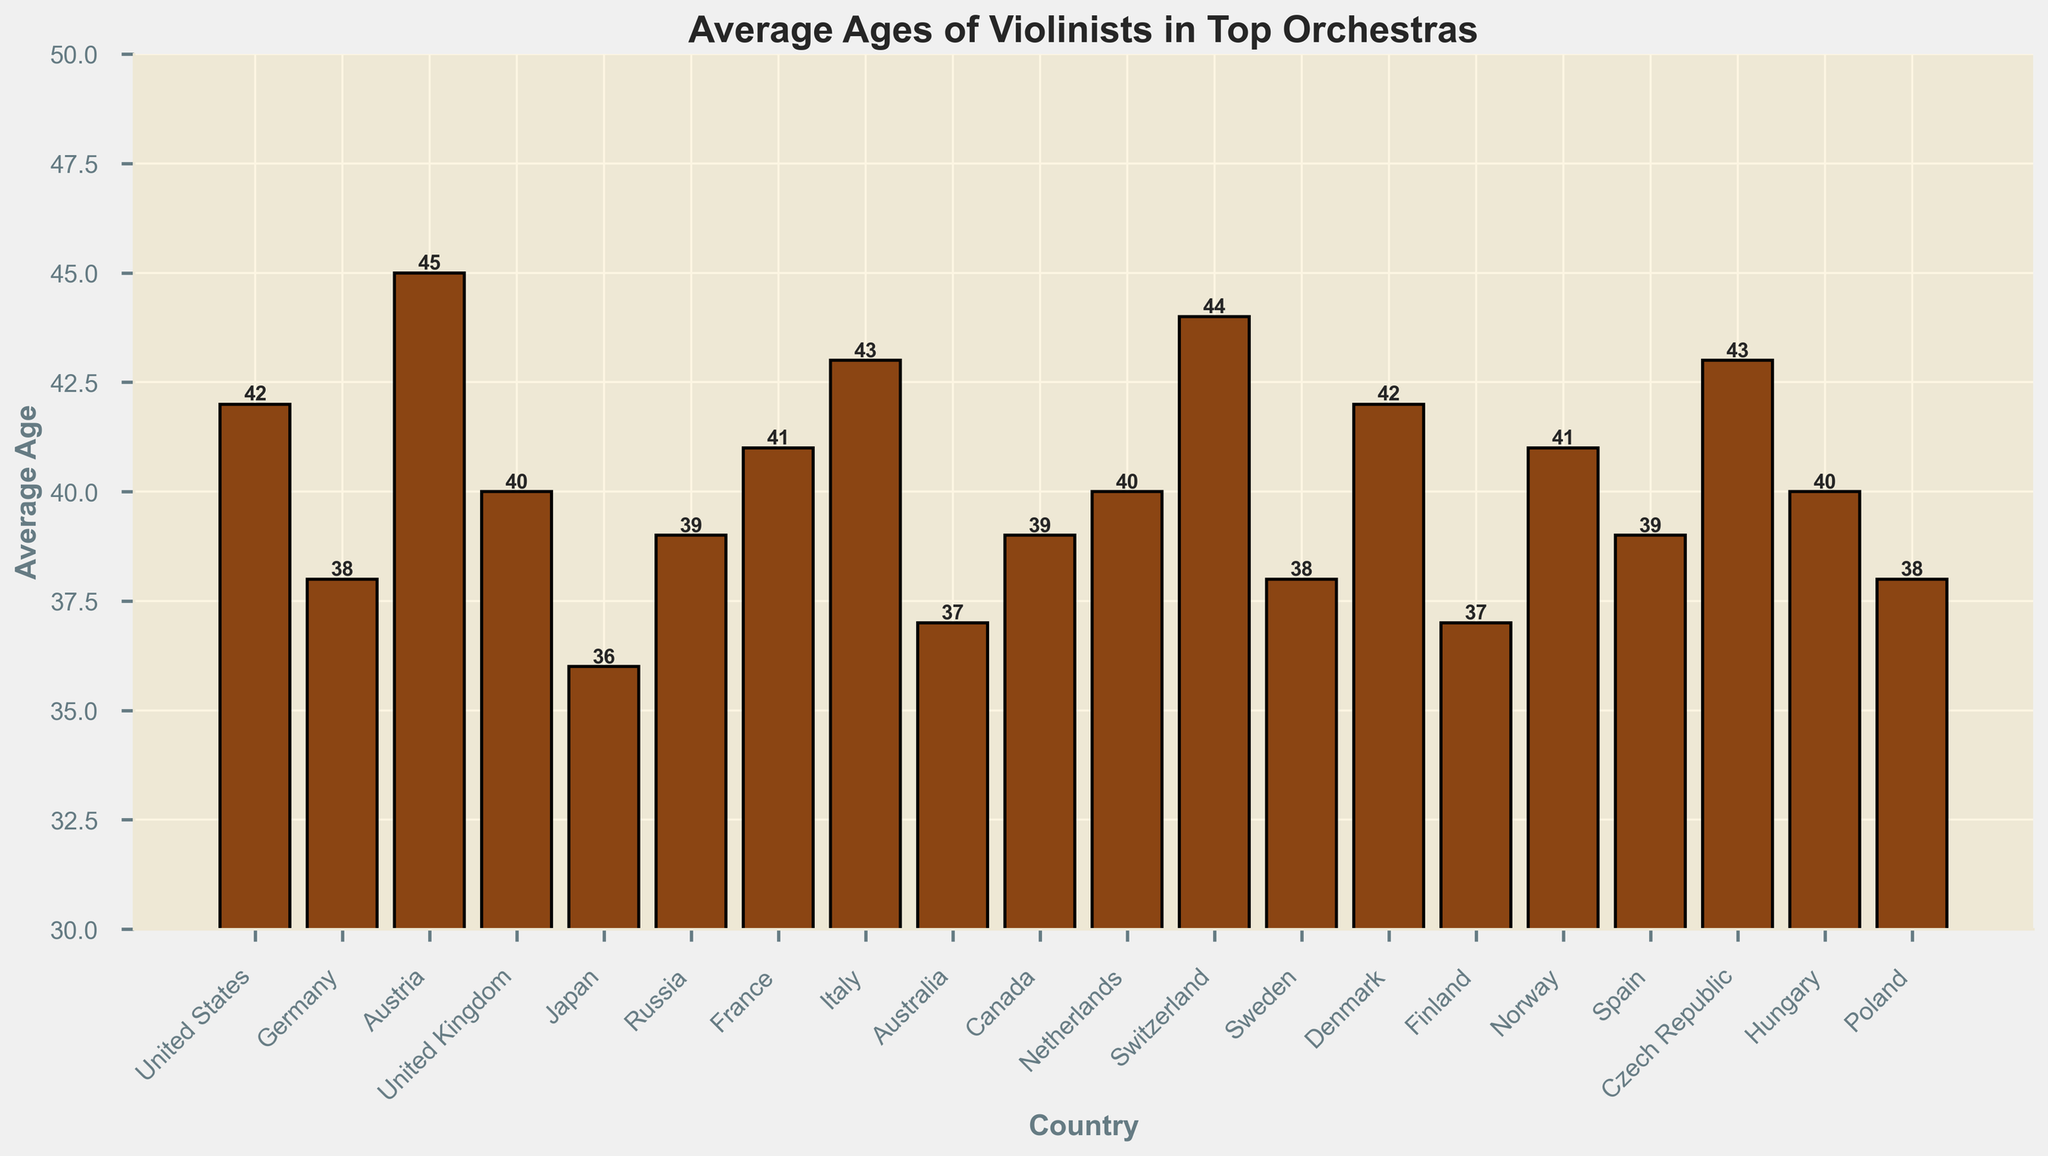Which country has the highest average age of violinists? The bar indicating the highest average age is observed by locating the tallest bar in the chart. The tallest bar represents Austria with an average age of 45.
Answer: Austria Which country has the lowest average age of violinists? The bar indicating the lowest average age can be identified by finding the shortest bar in the chart. The shortest bar represents Japan with an average age of 36.
Answer: Japan What is the difference in the average age of violinists between the United States and Germany? Look at the bars for the United States and Germany. The United States has an average age of 42 and Germany has 38. The difference is 42 - 38 = 4.
Answer: 4 How many countries have an average age of violinists 40 or above but below 45? Count the bars with an average age of 40, 41, 42, 43, and 44. These are the United States (42), United Kingdom (40), France (41), Norway (41), Italy (43), Czech Republic (43), Denmark (42), and Canada (40). In total, there are 8 countries.
Answer: 8 What is the average age of violinists in Australia? Locate the bar for Australia and read the value. The average age is 37.
Answer: 37 Which two countries have the same average age of violinists at 39? Identify the bars that peak at 39. The countries represented are Russia (39) and Spain (39).
Answer: Russia, Spain By how much does the average age of violinists in Finland differ from that in Switzerland? Look at the bars for Finland (37) and Switzerland (44). The difference is 44 - 37 = 7.
Answer: 7 Which is greater, the average age of violinists in Japan or Sweden? Compare the heights of the bars for Japan (36) and Sweden (38). Sweden's average age is greater.
Answer: Sweden Which continent has more countries with average ages of violinists above 40: Europe or North America? Count the European countries with ages above 40: Austria (45), Czech Republic (43), Denmark (42), France (41), Italy (43), Norway (41), Poland (38), Sweden (38), Germany (38), Hungary (40), UK (40), and Russia (39). This totals 10 countries. For North America, there are the United States (42) and Canada (39), giving a total of 1. Europe has more countries with average ages above 40.
Answer: Europe If we group the countries by continents, which continent has the highest combined average age for its top orchestras’ violinists? Sum the average ages for each country in a continent and find the total. For Europe: (42+38+45+40+39+41+43+40+38+37+44+38+41+39+43+40+38) = 648. For Asia: (36+38) = 74. For North America: (42+39) = 81. For Australia: 37. Europe has the highest combined average age.
Answer: Europe 